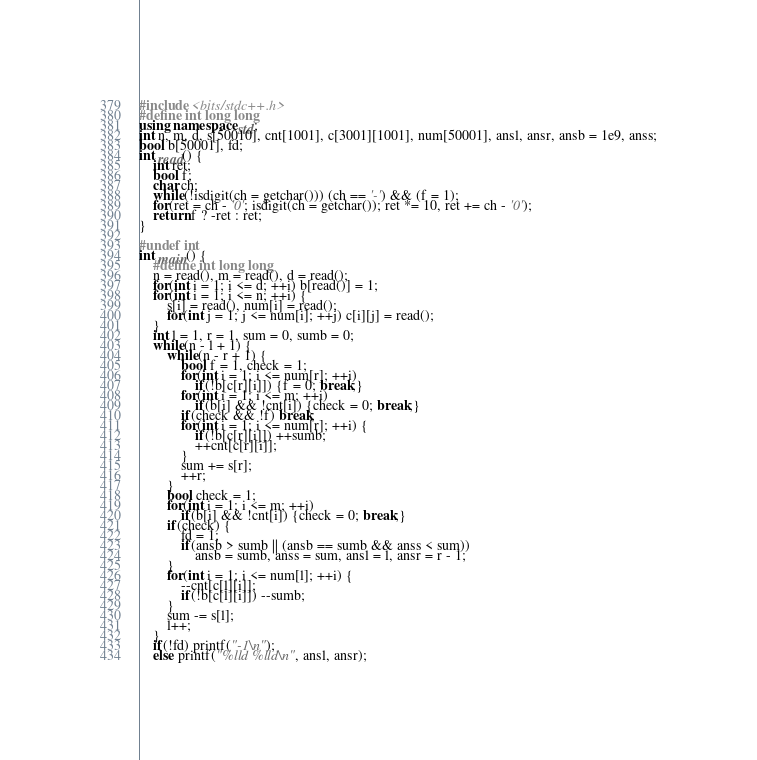Convert code to text. <code><loc_0><loc_0><loc_500><loc_500><_C++_>#include <bits/stdc++.h>
#define int long long
using namespace std;
int n, m, d, s[50010], cnt[1001], c[3001][1001], num[50001], ansl, ansr, ansb = 1e9, anss;
bool b[50001], fd;
int read() {
    int ret;
    bool f;
    char ch;
    while(!isdigit(ch = getchar())) (ch == '-') && (f = 1);
    for(ret = ch - '0'; isdigit(ch = getchar()); ret *= 10, ret += ch - '0');
    return f ? -ret : ret;
}

#undef int
int main() {
    #define int long long
    n = read(), m = read(), d = read();
    for(int i = 1; i <= d; ++i) b[read()] = 1;
    for(int i = 1; i <= n; ++i) {
        s[i] = read(), num[i] = read();
        for(int j = 1; j <= num[i]; ++j) c[i][j] = read();
    }
    int l = 1, r = 1, sum = 0, sumb = 0;
    while(n - l + 1) {
        while(n - r + 1) {
            bool f = 1, check = 1;
            for(int i = 1; i <= num[r]; ++i)
                if(!b[c[r][i]]) {f = 0; break;}
            for(int i = 1; i <= m; ++i)
                if(b[i] && !cnt[i]) {check = 0; break;}
            if(check && !f) break;
            for(int i = 1; i <= num[r]; ++i) {
                if(!b[c[r][i]]) ++sumb;
                ++cnt[c[r][i]];
            }
            sum += s[r];
            ++r;
        }
        bool check = 1;
        for(int i = 1; i <= m; ++i)
            if(b[i] && !cnt[i]) {check = 0; break;}
        if(check) {
            fd = 1;
            if(ansb > sumb || (ansb == sumb && anss < sum))
                ansb = sumb, anss = sum, ansl = l, ansr = r - 1;
        }
        for(int i = 1; i <= num[l]; ++i) {
            --cnt[c[l][i]];
            if(!b[c[l][i]]) --sumb;
        }
        sum -= s[l];
        l++;
    }
    if(!fd) printf("-1\n");
    else printf("%lld %lld\n", ansl, ansr);</code> 